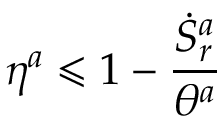<formula> <loc_0><loc_0><loc_500><loc_500>\eta ^ { a } \leqslant 1 - \frac { \dot { S } _ { r } ^ { a } } { \theta ^ { a } }</formula> 